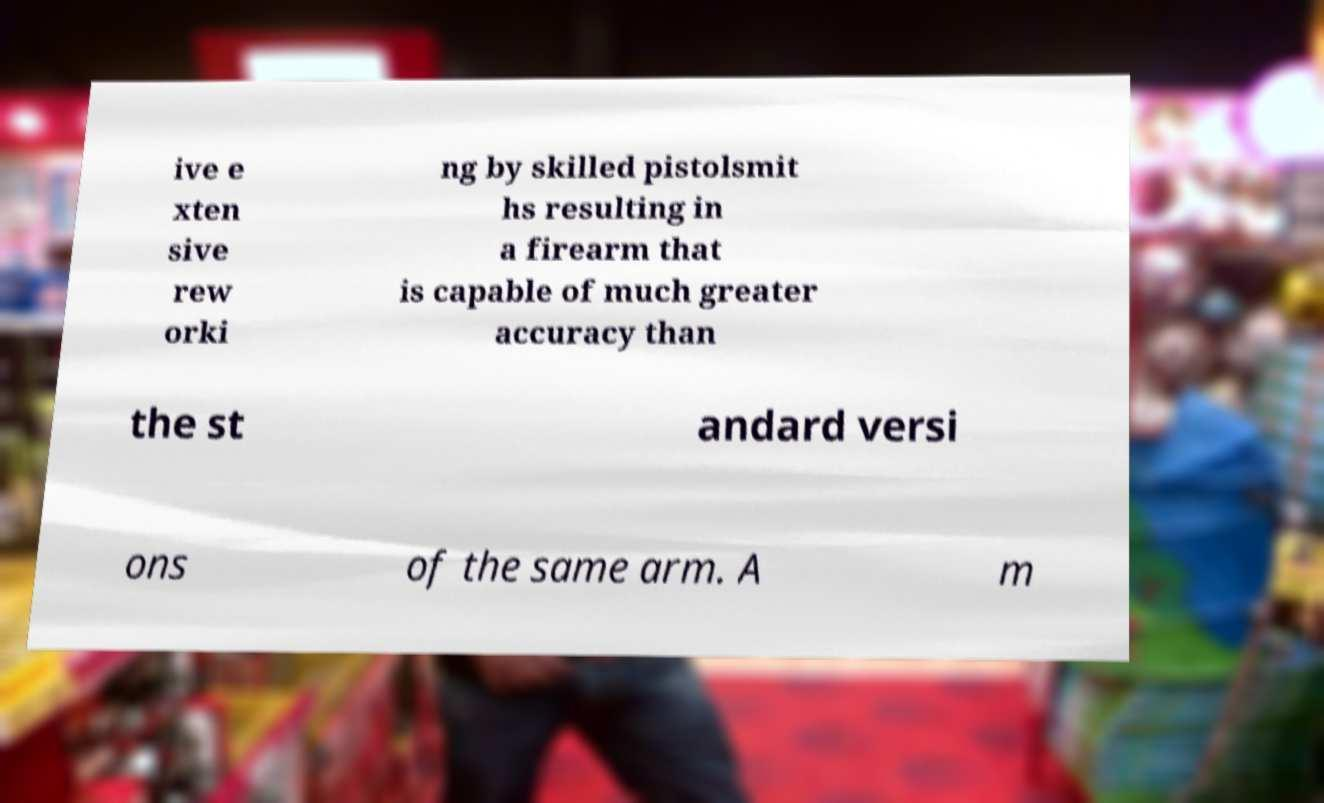Can you accurately transcribe the text from the provided image for me? ive e xten sive rew orki ng by skilled pistolsmit hs resulting in a firearm that is capable of much greater accuracy than the st andard versi ons of the same arm. A m 